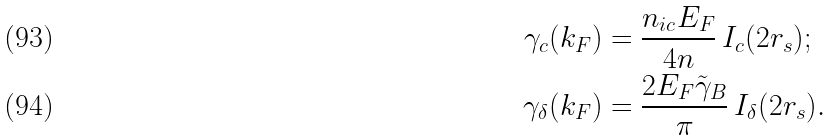<formula> <loc_0><loc_0><loc_500><loc_500>\gamma _ { c } ( k _ { F } ) & = \frac { n _ { i c } E _ { F } } { 4 n } \, I _ { c } ( 2 r _ { s } ) ; \\ \gamma _ { \delta } ( k _ { F } ) & = \frac { 2 E _ { F } \tilde { \gamma } _ { B } } { \pi } \, I _ { \delta } ( 2 r _ { s } ) .</formula> 